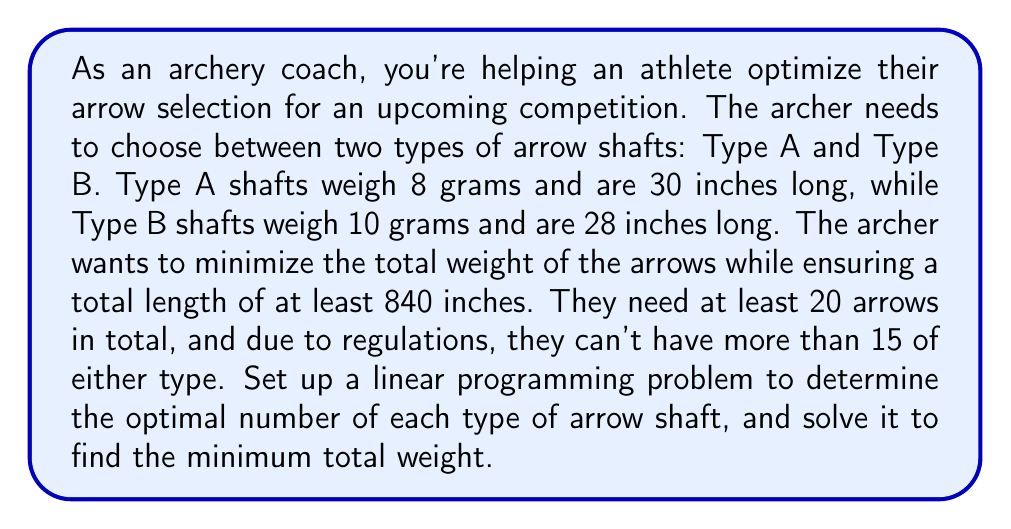Teach me how to tackle this problem. Let's approach this step-by-step:

1) Define variables:
   Let $x$ = number of Type A shafts
   Let $y$ = number of Type B shafts

2) Objective function:
   Minimize total weight: $Z = 8x + 10y$

3) Constraints:
   a) Total length: $30x + 28y \geq 840$
   b) Total number of arrows: $x + y \geq 20$
   c) Maximum of each type: $x \leq 15$ and $y \leq 15$
   d) Non-negativity: $x \geq 0$ and $y \geq 0$

4) The complete linear programming problem:

   Minimize $Z = 8x + 10y$
   Subject to:
   $$\begin{align}
   30x + 28y &\geq 840 \\
   x + y &\geq 20 \\
   x &\leq 15 \\
   y &\leq 15 \\
   x, y &\geq 0
   \end{align}$$

5) To solve this, we can use the graphical method:

   [asy]
   import geometry;

   size(200);
   
   // Draw axes
   draw((-1,0)--(20,0), arrow=Arrow);
   draw((0,-1)--(0,20), arrow=Arrow);
   
   // Label axes
   label("x", (20,0), E);
   label("y", (0,20), N);
   
   // Draw constraints
   draw((0,30)--(28,0), blue);
   draw((20,0)--(0,20), red);
   draw((15,0)--(15,20), green);
   draw((0,15)--(20,15), purple);
   
   // Shade feasible region
   fill((15,15)--(15,20)--(20,20)--(20,15)--cycle, lightgray);
   
   // Label points
   dot((15,15));
   label("(15,15)", (15,15), NE);
   
   // Legend
   label("30x + 28y = 840", (10,25), blue);
   label("x + y = 20", (20,5), red);
   label("x = 15", (15,10), E, green);
   label("y = 15", (10,15), N, purple);
   [/asy]

6) The feasible region is the shaded area. The optimal solution will be at one of the corner points. Evaluating the objective function at each corner point:

   At (15, 15): $Z = 8(15) + 10(15) = 270$
   At (15, 5): $Z = 8(15) + 10(5) = 170$
   At (20, 0): $Z = 8(20) + 10(0) = 160$

7) The minimum value of Z is 160, occurring at the point (20, 0).
Answer: The optimal solution is to select 20 Type A arrow shafts and 0 Type B arrow shafts, resulting in a minimum total weight of 160 grams. 